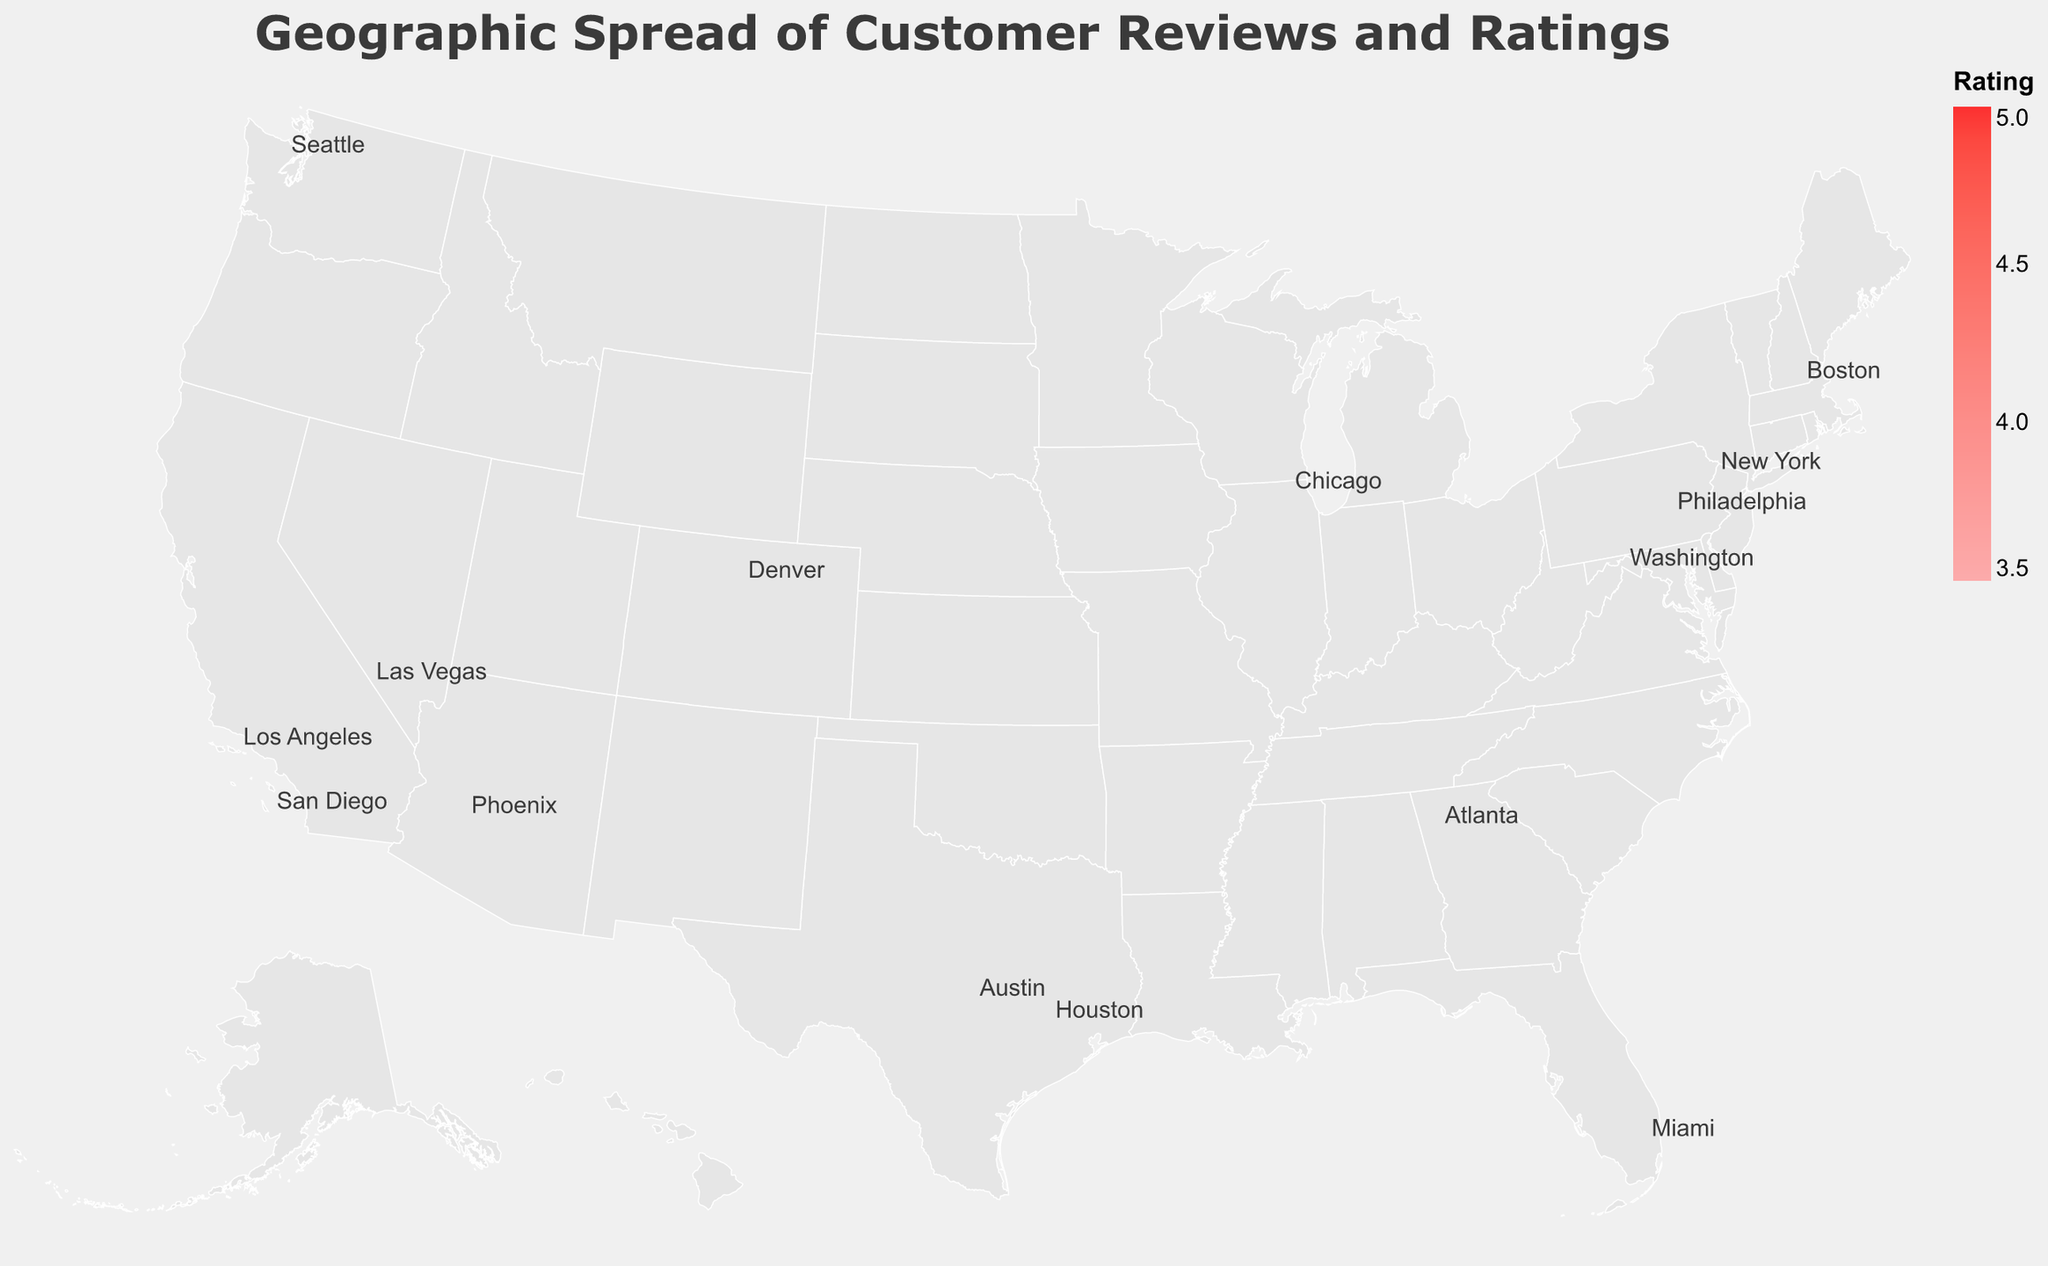Which city has the highest customer rating? Look at the circles' color and find the highest rating value. Las Vegas has a rating of 4.8, the highest among all the cities.
Answer: Las Vegas Which city has the lowest customer rating? Look at the circles' color and find the lowest rating value. Phoenix has a rating of 3.7, the lowest among all the cities.
Answer: Phoenix How many cities have a customer rating of 4.5 or higher? Review the colors and identify cities with ratings of 4.5, 4.6, 4.7, and 4.8. There are four such cities: Los Angeles, Boston, Seattle, and Las Vegas.
Answer: 4 Which city has the highest number of reviews? Check the size of the circles and look for the largest one. New York has the largest circle with 150 reviews.
Answer: New York Compare the customer ratings between New York and Chicago. Which city has a higher rating? Locate New York and Chicago on the map. Compare their colors. New York has a rating of 4.2, while Chicago has a rating of 3.8.
Answer: New York Which states are represented in the plot? Identify the states corresponding to each city's location and name. The states are NY, CA, IL, TX, GA, PA, MA, CO, WA, DC, AZ, NV, and FL.
Answer: NY, CA, IL, TX, GA, PA, MA, CO, WA, DC, AZ, NV, FL What is the average rating for all cities combined? Sum all the ratings and divide by the number of cities: (4.2+4.5+3.8+4.1+4.3+3.9+4.7+4.4+4.0+4.6+4.2+3.7+4.8+4.5+4.0)/15 = 63.7/15 ≈ 4.25.
Answer: 4.25 How does the geographic spread of high-satisfaction areas (rating >= 4.5) compare to low-satisfaction areas (rating <= 4.0)? Identify high-satisfaction areas with ratings 4.5 or higher and low-satisfaction areas with ratings 4.0 or lower. High-satisfaction areas are Los Angeles, Boston, Seattle, Las Vegas, and Austin. Low-satisfaction areas are Chicago, Philadelphia, Denver, Phoenix, and Miami. High-satisfaction areas are more evenly spread out, while low-satisfaction areas are located more towards the northeastern and southwestern parts of the map.
Answer: High-satisfaction areas more spread out 